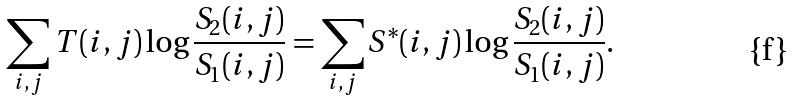Convert formula to latex. <formula><loc_0><loc_0><loc_500><loc_500>\sum _ { i , j } T ( i , j ) \log \frac { S _ { 2 } ( i , j ) } { S _ { 1 } ( i , j ) } = \sum _ { i , j } S ^ { * } ( i , j ) \log \frac { S _ { 2 } ( i , j ) } { S _ { 1 } ( i , j ) } .</formula> 